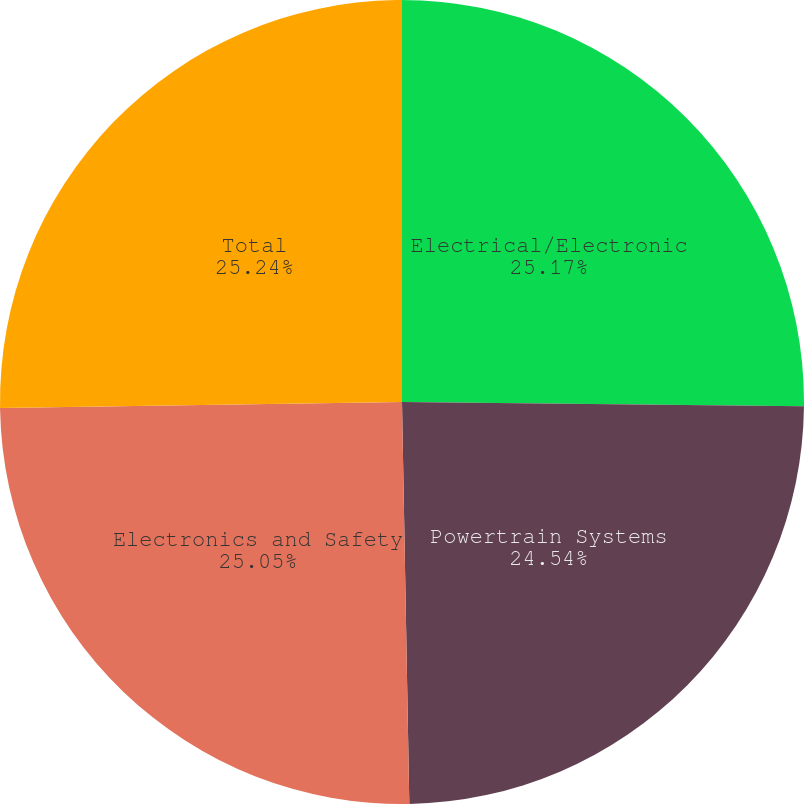Convert chart to OTSL. <chart><loc_0><loc_0><loc_500><loc_500><pie_chart><fcel>Electrical/Electronic<fcel>Powertrain Systems<fcel>Electronics and Safety<fcel>Total<nl><fcel>25.17%<fcel>24.54%<fcel>25.05%<fcel>25.24%<nl></chart> 